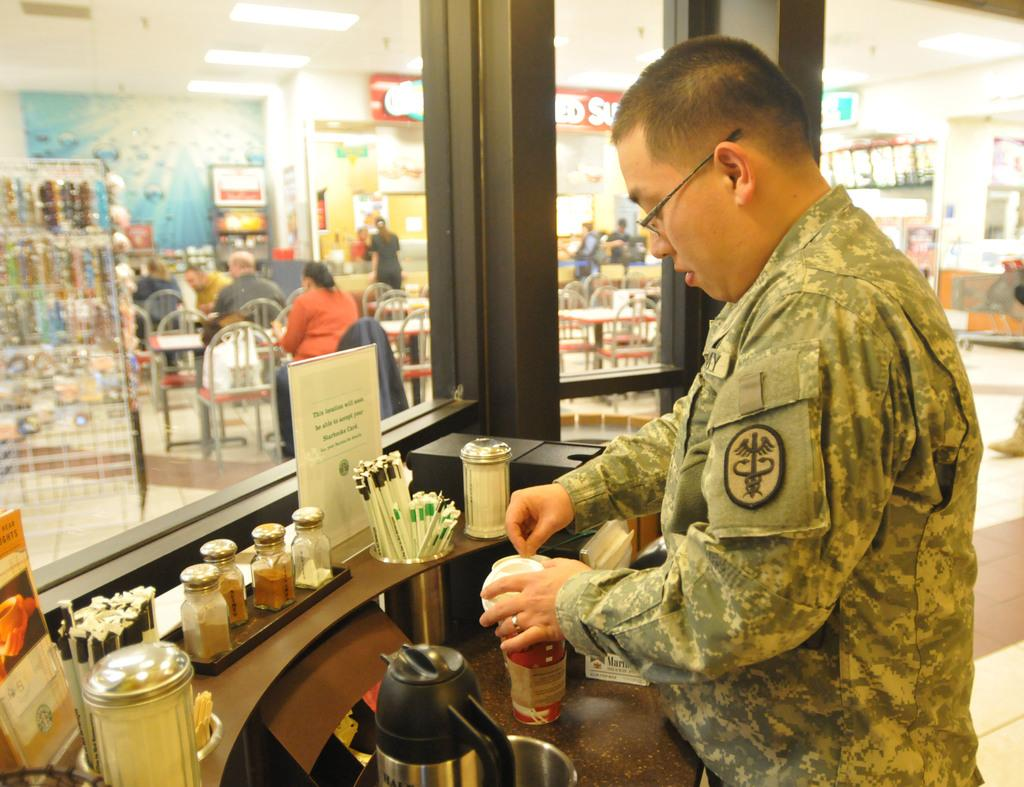How many people are present in the image? There are people in the image, but the exact number cannot be determined from the provided facts. What type of furniture is visible in the image? Chairs and tables are visible in the image. What is the background of the image? There is a wall in the image, which suggests it is an indoor setting. What decorative elements are present in the image? Banners are present in the image. What other objects can be seen in the image? There is a rack, paper, and bottles visible in the image. Where is the basin located in the image? There is no basin present in the image. What type of pail is being used by the people in the image? There are no pails visible in the image. 